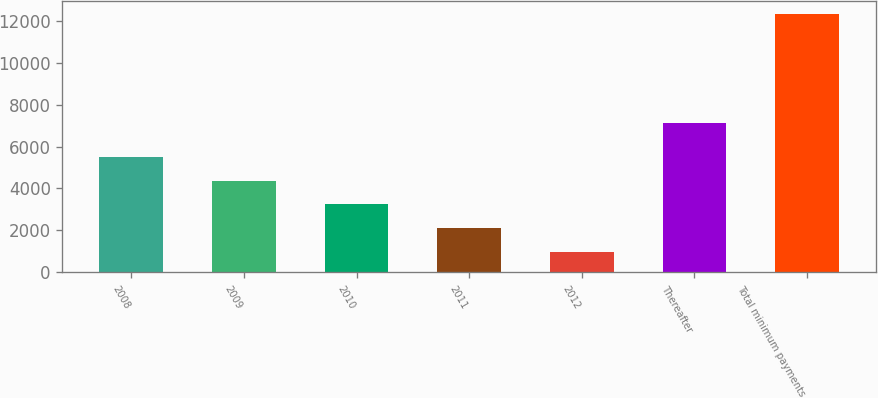Convert chart. <chart><loc_0><loc_0><loc_500><loc_500><bar_chart><fcel>2008<fcel>2009<fcel>2010<fcel>2011<fcel>2012<fcel>Thereafter<fcel>Total minimum payments<nl><fcel>5504.46<fcel>4368.17<fcel>3231.88<fcel>2095.59<fcel>959.3<fcel>7117.7<fcel>12322.2<nl></chart> 